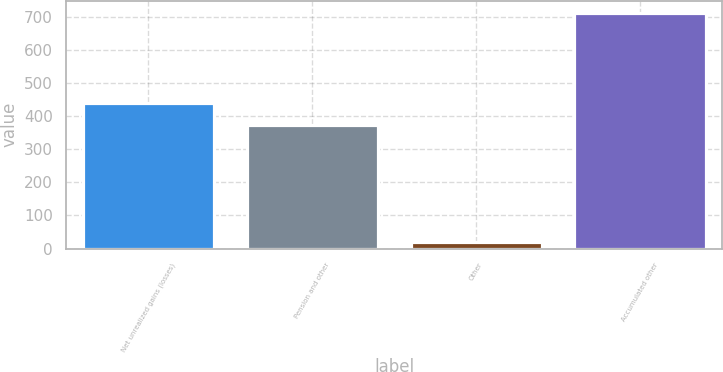<chart> <loc_0><loc_0><loc_500><loc_500><bar_chart><fcel>Net unrealized gains (losses)<fcel>Pension and other<fcel>Other<fcel>Accumulated other<nl><fcel>439.3<fcel>374<fcel>20<fcel>712.3<nl></chart> 